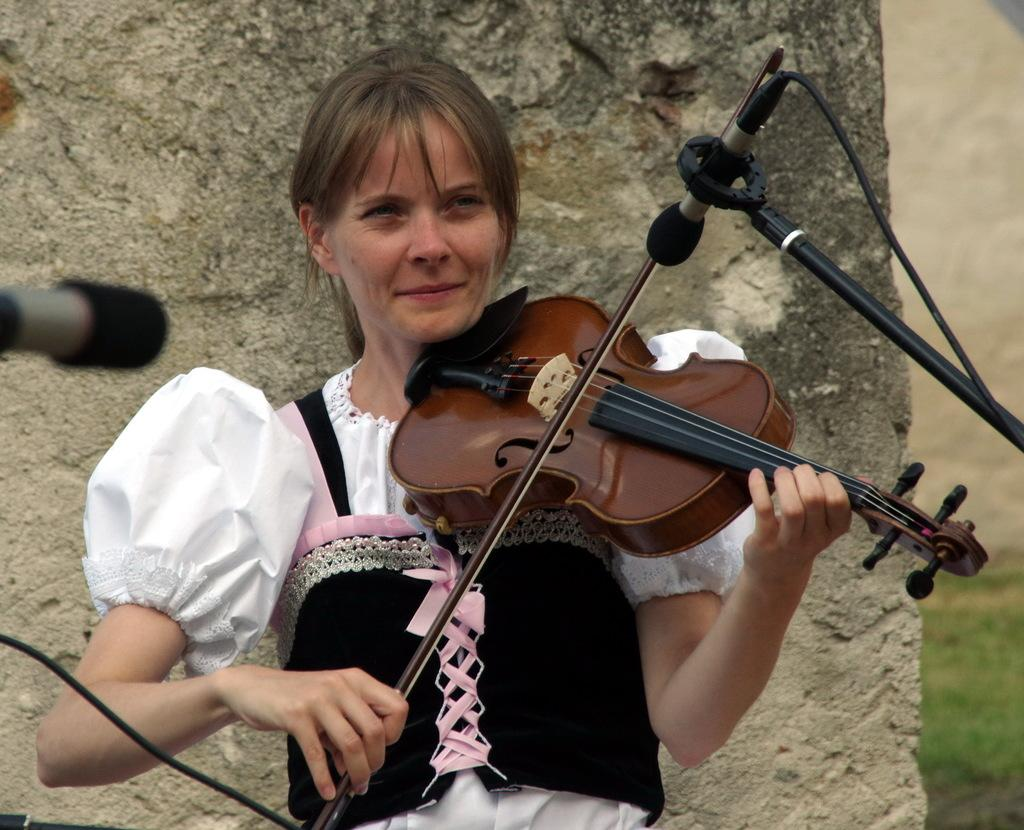Who is the main subject in the image? There is a woman in the image. What is the woman doing in the image? The woman is smiling and holding a violin. What object is in front of the woman? There is a microphone in front of the woman. What can be seen in the background of the image? There is a wall and grass in the background of the image. What type of line is the woman waiting in the image? There is no line present in the image; the woman is holding a violin and standing in front of a microphone. Can you tell me how the stranger is interacting with the woman in the image? There is no stranger present in the image; the woman is alone with her violin and the microphone. 